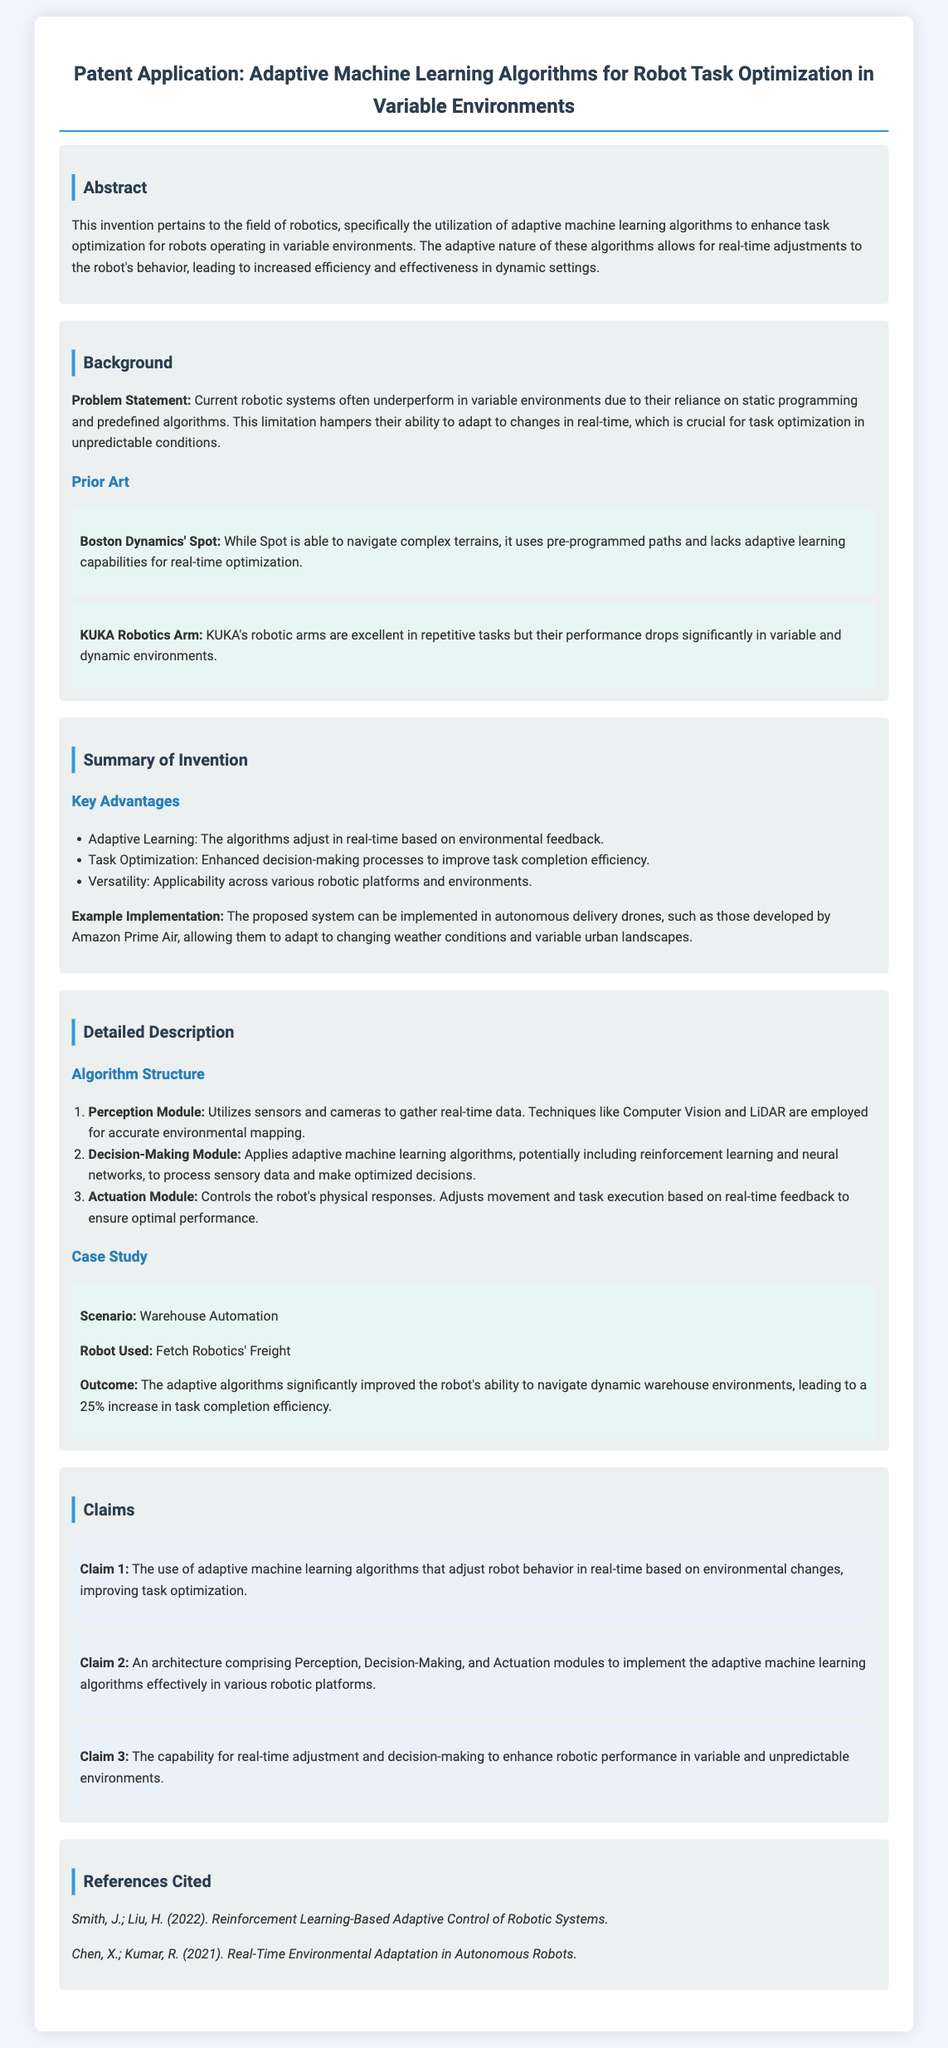What is the title of the patent application? The title is prominently displayed at the top of the document, indicating the focus of the invention.
Answer: Adaptive Machine Learning Algorithms for Robot Task Optimization in Variable Environments What is the key advantage of the proposed system? The document lists multiple advantages under the summary of the invention, highlighting the benefits of the adaptive algorithms.
Answer: Adaptive Learning What is the outcome of the case study in warehouse automation? The outcome section details the effectiveness of the adaptive algorithms in a real-world scenario.
Answer: 25% increase in task completion efficiency What is the first claim of the patent application? The claims section articulates specific assertions regarding the invention's originality and novelty, starting with the most prominent claim.
Answer: The use of adaptive machine learning algorithms that adjust robot behavior in real-time based on environmental changes, improving task optimization Which robot was used in the case study? The robot mentioned in the case study is explicitly stated, showcasing a practical application of the adaptive algorithms.
Answer: Fetch Robotics' Freight What techniques are employed in the Perception Module? Key methods employed for data gathering and environmental mapping are outlined in the detailed description of the algorithm structure.
Answer: Computer Vision and LiDAR What is the primary problem addressed by this invention? The background section clearly defines the limitations of current robotic systems that the invention seeks to overcome.
Answer: Reliance on static programming What are the three main modules of the proposed architecture? The detailed description provides an overview of the components that constitute the system's architecture.
Answer: Perception, Decision-Making, Actuation 